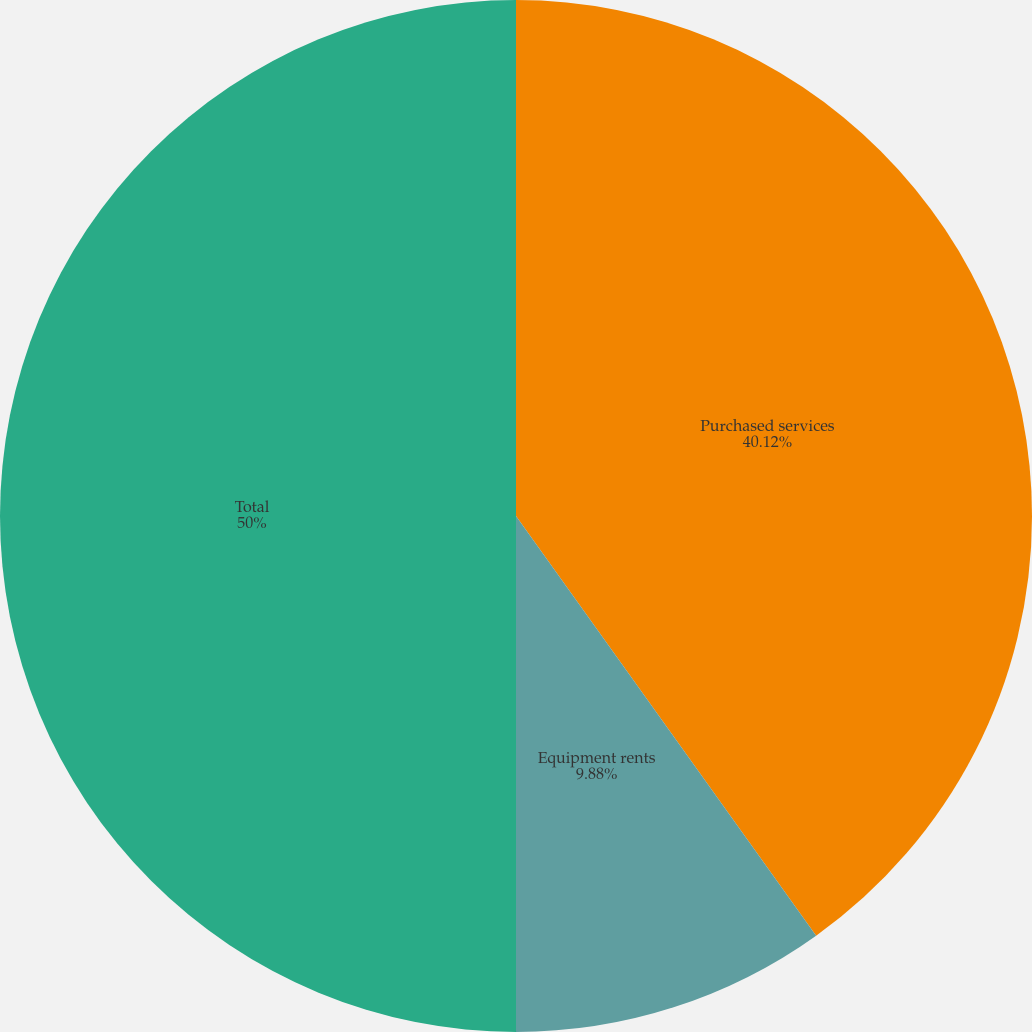<chart> <loc_0><loc_0><loc_500><loc_500><pie_chart><fcel>Purchased services<fcel>Equipment rents<fcel>Total<nl><fcel>40.12%<fcel>9.88%<fcel>50.0%<nl></chart> 